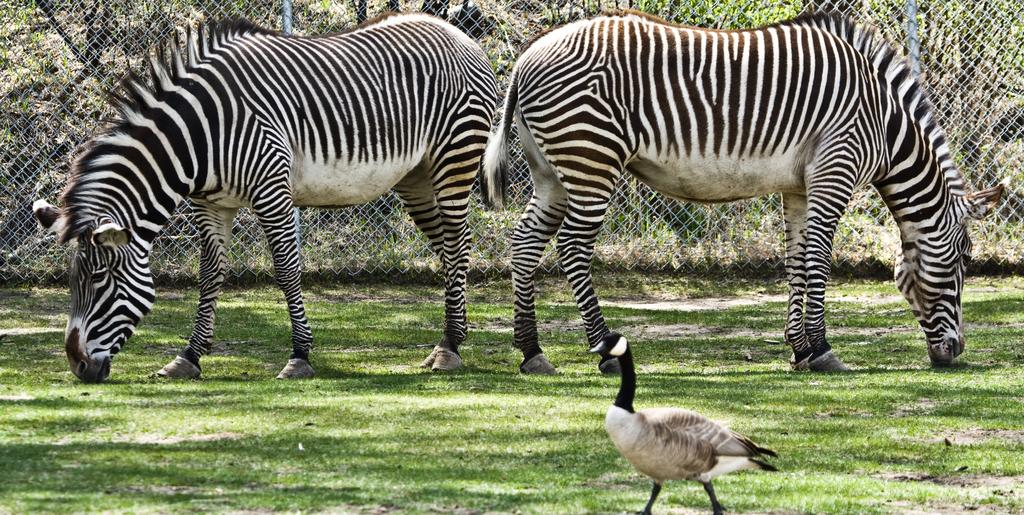What type of outdoor space is shown in the image? There is a garden in the image. What animals can be seen in the garden? Two zebras are standing in the garden. Are there any other living creatures in the image? Yes, there is a bird in the image. What is the structure surrounding the garden? There is a boundary wall in the image, which is made of iron grill. What type of vegetation is present in the garden? There is grass in the image. How many sisters are sitting in the tub in the image? There is no tub or sisters present in the image. 